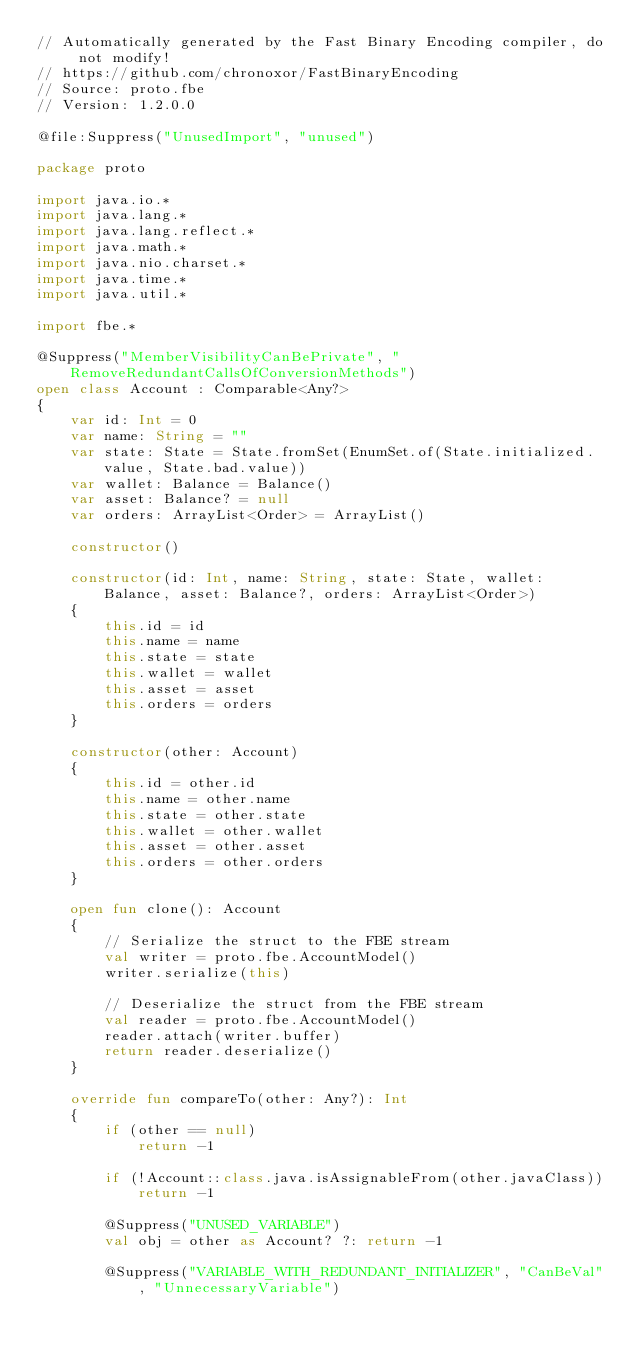Convert code to text. <code><loc_0><loc_0><loc_500><loc_500><_Kotlin_>// Automatically generated by the Fast Binary Encoding compiler, do not modify!
// https://github.com/chronoxor/FastBinaryEncoding
// Source: proto.fbe
// Version: 1.2.0.0

@file:Suppress("UnusedImport", "unused")

package proto

import java.io.*
import java.lang.*
import java.lang.reflect.*
import java.math.*
import java.nio.charset.*
import java.time.*
import java.util.*

import fbe.*

@Suppress("MemberVisibilityCanBePrivate", "RemoveRedundantCallsOfConversionMethods")
open class Account : Comparable<Any?>
{
    var id: Int = 0
    var name: String = ""
    var state: State = State.fromSet(EnumSet.of(State.initialized.value, State.bad.value))
    var wallet: Balance = Balance()
    var asset: Balance? = null
    var orders: ArrayList<Order> = ArrayList()

    constructor()

    constructor(id: Int, name: String, state: State, wallet: Balance, asset: Balance?, orders: ArrayList<Order>)
    {
        this.id = id
        this.name = name
        this.state = state
        this.wallet = wallet
        this.asset = asset
        this.orders = orders
    }

    constructor(other: Account)
    {
        this.id = other.id
        this.name = other.name
        this.state = other.state
        this.wallet = other.wallet
        this.asset = other.asset
        this.orders = other.orders
    }

    open fun clone(): Account
    {
        // Serialize the struct to the FBE stream
        val writer = proto.fbe.AccountModel()
        writer.serialize(this)

        // Deserialize the struct from the FBE stream
        val reader = proto.fbe.AccountModel()
        reader.attach(writer.buffer)
        return reader.deserialize()
    }

    override fun compareTo(other: Any?): Int
    {
        if (other == null)
            return -1

        if (!Account::class.java.isAssignableFrom(other.javaClass))
            return -1

        @Suppress("UNUSED_VARIABLE")
        val obj = other as Account? ?: return -1

        @Suppress("VARIABLE_WITH_REDUNDANT_INITIALIZER", "CanBeVal", "UnnecessaryVariable")</code> 